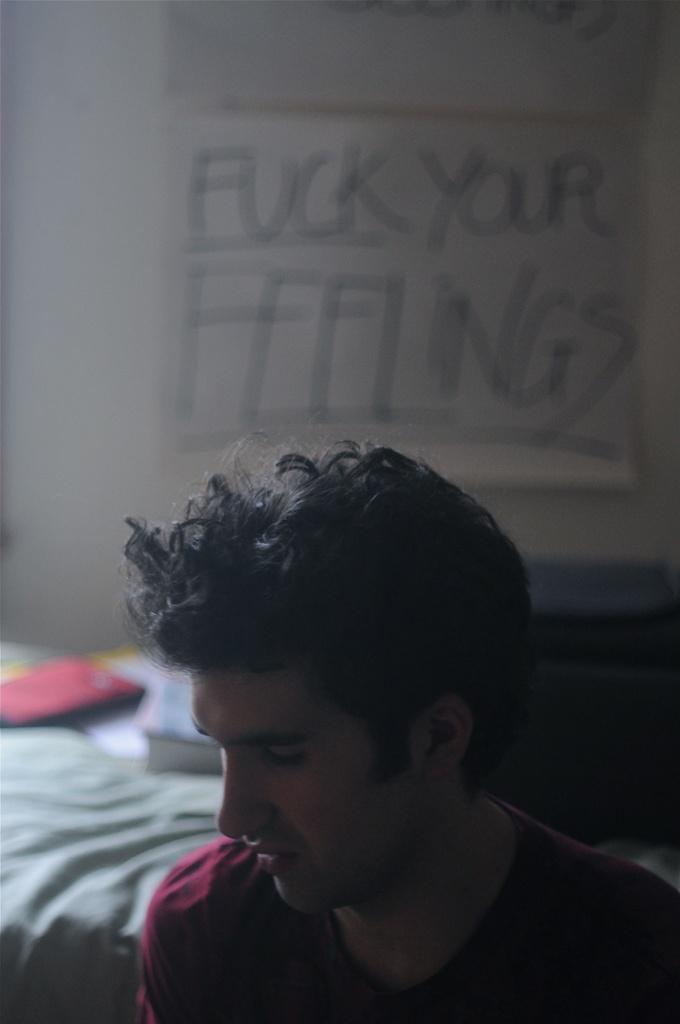In one or two sentences, can you explain what this image depicts? In this picture there is a person wearing red T-shirt and there are few books behind him and there is a paper which has fuck your feelings written on it is attached to the wall in the background. 